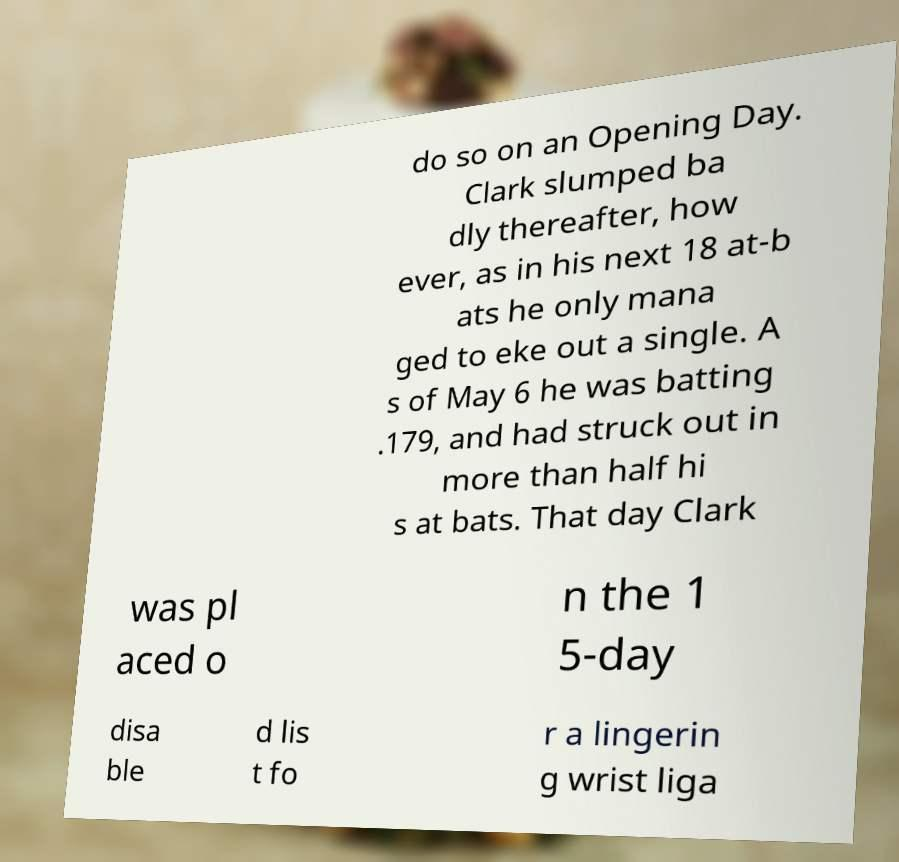Can you accurately transcribe the text from the provided image for me? do so on an Opening Day. Clark slumped ba dly thereafter, how ever, as in his next 18 at-b ats he only mana ged to eke out a single. A s of May 6 he was batting .179, and had struck out in more than half hi s at bats. That day Clark was pl aced o n the 1 5-day disa ble d lis t fo r a lingerin g wrist liga 